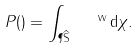<formula> <loc_0><loc_0><loc_500><loc_500>P ( \tt ) = \int _ { \P \widehat { S } } \ \tt ^ { \, \ v v } \, d \chi .</formula> 